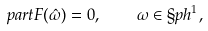Convert formula to latex. <formula><loc_0><loc_0><loc_500><loc_500>\real p a r t F ( \hat { \omega } ) = 0 , \quad \omega \in \S p h ^ { 1 } ,</formula> 